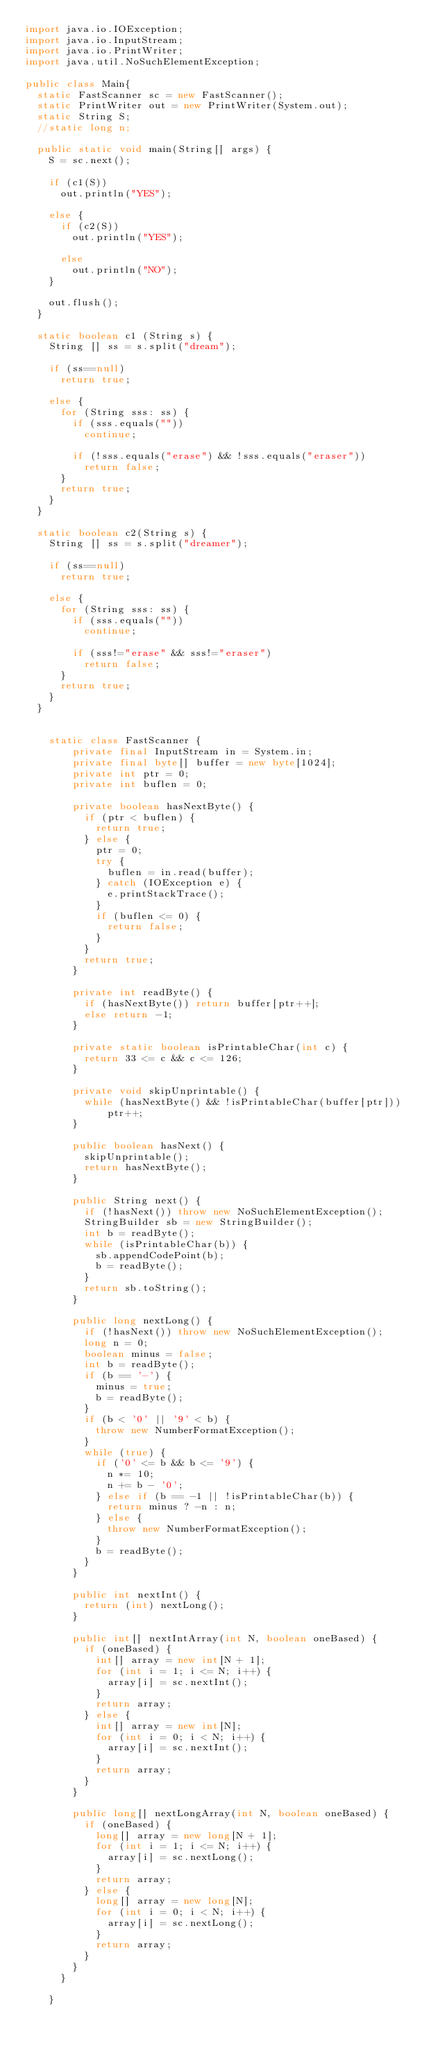<code> <loc_0><loc_0><loc_500><loc_500><_Java_>import java.io.IOException;
import java.io.InputStream;
import java.io.PrintWriter;
import java.util.NoSuchElementException;

public class Main{
	static FastScanner sc = new FastScanner();
	static PrintWriter out = new PrintWriter(System.out);
	static String S;
	//static long n;
	
	public static void main(String[] args) {
		S = sc.next();
		
		if (c1(S))
			out.println("YES");
		
		else {
			if (c2(S))
				out.println("YES");
			
			else
				out.println("NO");	
		}
		
		out.flush();
	}
	
	static boolean c1 (String s) {
		String [] ss = s.split("dream");
		
		if (ss==null)
			return true;
		
		else {
			for (String sss: ss) {
				if (sss.equals(""))
					continue;
				
				if (!sss.equals("erase") && !sss.equals("eraser"))
					return false;
			}
			return true;
		}
	}
	
	static boolean c2(String s) {
		String [] ss = s.split("dreamer");
		
		if (ss==null)
			return true;
		
		else {
			for (String sss: ss) {
				if (sss.equals(""))
					continue;
				
				if (sss!="erase" && sss!="eraser")
					return false;
			}
			return true;
		}
	}
	
	
		static class FastScanner {
		    private final InputStream in = System.in;
		    private final byte[] buffer = new byte[1024];
		    private int ptr = 0;
		    private int buflen = 0;

		    private boolean hasNextByte() {
		      if (ptr < buflen) {
		        return true;
		      } else {
		        ptr = 0;
		        try {
		          buflen = in.read(buffer);
		        } catch (IOException e) {
		          e.printStackTrace();
		        }
		        if (buflen <= 0) {
		          return false;
		        }
		      }
		      return true;
		    }

		    private int readByte() {
		      if (hasNextByte()) return buffer[ptr++];
		      else return -1;
		    }

		    private static boolean isPrintableChar(int c) {
		      return 33 <= c && c <= 126;
		    }

		    private void skipUnprintable() {
		      while (hasNextByte() && !isPrintableChar(buffer[ptr])) ptr++;
		    }

		    public boolean hasNext() {
		      skipUnprintable();
		      return hasNextByte();
		    }

		    public String next() {
		      if (!hasNext()) throw new NoSuchElementException();
		      StringBuilder sb = new StringBuilder();
		      int b = readByte();
		      while (isPrintableChar(b)) {
		        sb.appendCodePoint(b);
		        b = readByte();
		      }
		      return sb.toString();
		    }

		    public long nextLong() {
		      if (!hasNext()) throw new NoSuchElementException();
		      long n = 0;
		      boolean minus = false;
		      int b = readByte();
		      if (b == '-') {
		        minus = true;
		        b = readByte();
		      }
		      if (b < '0' || '9' < b) {
		        throw new NumberFormatException();
		      }
		      while (true) {
		        if ('0' <= b && b <= '9') {
		          n *= 10;
		          n += b - '0';
		        } else if (b == -1 || !isPrintableChar(b)) {
		          return minus ? -n : n;
		        } else {
		          throw new NumberFormatException();
		        }
		        b = readByte();
		      }
		    }

		    public int nextInt() {
		      return (int) nextLong();
		    }

		    public int[] nextIntArray(int N, boolean oneBased) {
		      if (oneBased) {
		        int[] array = new int[N + 1];
		        for (int i = 1; i <= N; i++) {
		          array[i] = sc.nextInt();
		        }
		        return array;
		      } else {
		        int[] array = new int[N];
		        for (int i = 0; i < N; i++) {
		          array[i] = sc.nextInt();
		        }
		        return array;
		      }
		    }

		    public long[] nextLongArray(int N, boolean oneBased) {
		      if (oneBased) {
		        long[] array = new long[N + 1];
		        for (int i = 1; i <= N; i++) {
		          array[i] = sc.nextLong();
		        }
		        return array;
		      } else {
		        long[] array = new long[N];
		        for (int i = 0; i < N; i++) {
		          array[i] = sc.nextLong();
		        }
		        return array;
		      }
		    }
		  }

		}	 



</code> 